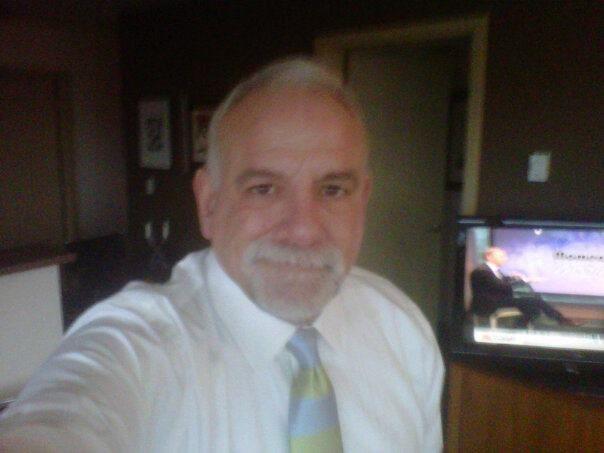Who is holding a camera?
Write a very short answer. Man. Is the older man wearing a hat?
Keep it brief. No. How many phones does he have?
Answer briefly. 0. How many men's faces are shown?
Short answer required. 1. What direction is the person looking in?
Answer briefly. Forward. What is on their foreheads?
Concise answer only. Nothing. What is on the man's face?
Be succinct. Beard. What are the men wearing?
Quick response, please. Shirt and tie. What color is the wall?
Write a very short answer. Brown. Does this man have glasses on?
Concise answer only. No. Could this be a fuzzy "selfie"?
Quick response, please. Yes. What is on?
Be succinct. Tv. What is on the man's tie?
Be succinct. Stripes. Does the man have a full beard?
Quick response, please. No. What is the elder man doing in the picture?
Answer briefly. Smiling. Is the man wearing glasses?
Write a very short answer. No. What is on this man's face?
Give a very brief answer. Beard. What is the man doing?
Be succinct. Taking selfie. What color shirt is the man wearing?
Short answer required. White. Does this man's smile look a little bit evil?
Quick response, please. No. What color are the clothes in the drawer?
Short answer required. White. What color is the man's tie?
Concise answer only. Green and blue. What is hanging on the wall?
Quick response, please. Pictures. Does the room have wood paneling on its walls?
Give a very brief answer. Yes. Why this man is too happy?
Short answer required. He isn't. Who is the picture of the guy on the shirt?
Quick response, please. No guy on shirt. How many light switches are there?
Short answer required. 1. 